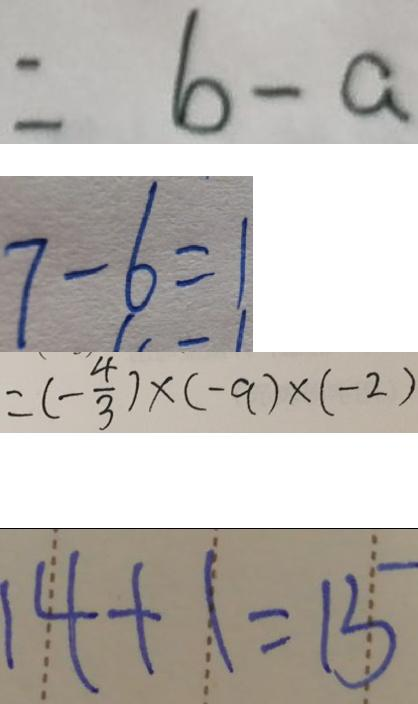<formula> <loc_0><loc_0><loc_500><loc_500>= b - a 
 7 - 6 = 1 
 = ( - \frac { 4 } { 3 } ) \times ( - 9 ) \times ( - 2 ) 
 1 4 + 1 = 1 5</formula> 